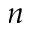<formula> <loc_0><loc_0><loc_500><loc_500>n</formula> 